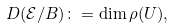<formula> <loc_0><loc_0><loc_500><loc_500>D ( \mathcal { E } / B ) \colon = \dim \rho ( U ) ,</formula> 